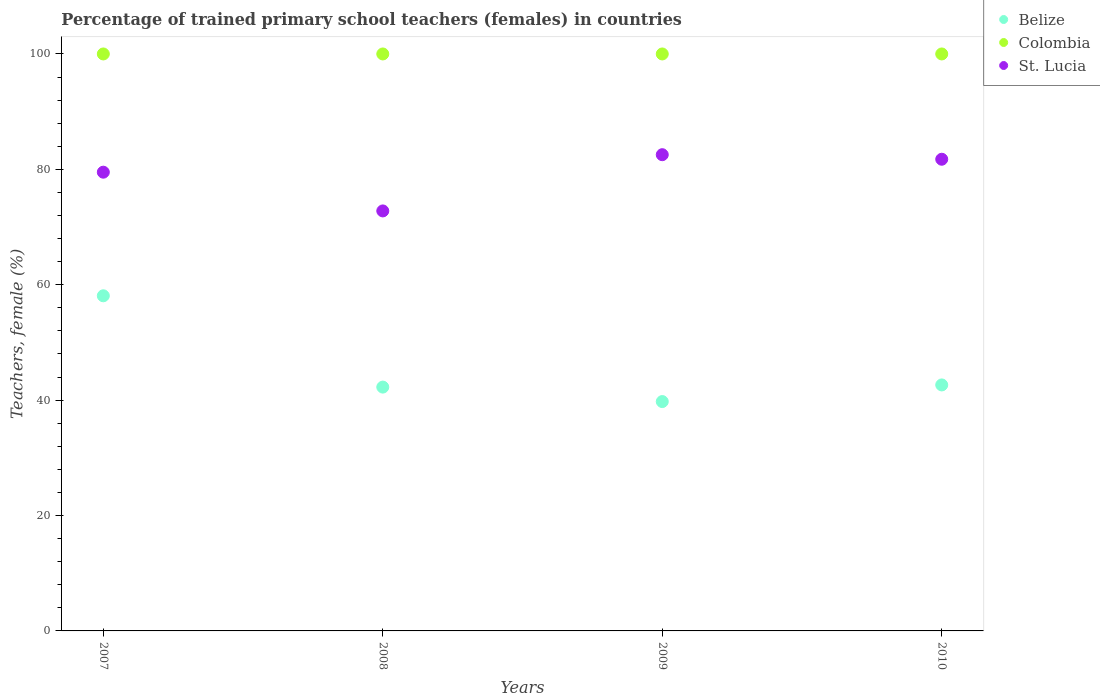Is the number of dotlines equal to the number of legend labels?
Give a very brief answer. Yes. What is the percentage of trained primary school teachers (females) in Belize in 2009?
Your answer should be very brief. 39.75. Across all years, what is the maximum percentage of trained primary school teachers (females) in Belize?
Your response must be concise. 58.08. Across all years, what is the minimum percentage of trained primary school teachers (females) in Belize?
Offer a terse response. 39.75. What is the total percentage of trained primary school teachers (females) in Belize in the graph?
Provide a succinct answer. 182.73. What is the difference between the percentage of trained primary school teachers (females) in Belize in 2008 and that in 2010?
Offer a very short reply. -0.38. What is the difference between the percentage of trained primary school teachers (females) in St. Lucia in 2010 and the percentage of trained primary school teachers (females) in Colombia in 2007?
Provide a succinct answer. -18.25. What is the average percentage of trained primary school teachers (females) in St. Lucia per year?
Make the answer very short. 79.15. In the year 2008, what is the difference between the percentage of trained primary school teachers (females) in Colombia and percentage of trained primary school teachers (females) in Belize?
Keep it short and to the point. 57.74. What is the ratio of the percentage of trained primary school teachers (females) in St. Lucia in 2007 to that in 2010?
Your answer should be compact. 0.97. What is the difference between the highest and the second highest percentage of trained primary school teachers (females) in Belize?
Your response must be concise. 15.45. What is the difference between the highest and the lowest percentage of trained primary school teachers (females) in St. Lucia?
Offer a terse response. 9.75. In how many years, is the percentage of trained primary school teachers (females) in St. Lucia greater than the average percentage of trained primary school teachers (females) in St. Lucia taken over all years?
Keep it short and to the point. 3. Is it the case that in every year, the sum of the percentage of trained primary school teachers (females) in Belize and percentage of trained primary school teachers (females) in St. Lucia  is greater than the percentage of trained primary school teachers (females) in Colombia?
Provide a short and direct response. Yes. Does the percentage of trained primary school teachers (females) in Colombia monotonically increase over the years?
Offer a terse response. No. Is the percentage of trained primary school teachers (females) in St. Lucia strictly less than the percentage of trained primary school teachers (females) in Colombia over the years?
Provide a short and direct response. Yes. Are the values on the major ticks of Y-axis written in scientific E-notation?
Ensure brevity in your answer.  No. How many legend labels are there?
Your response must be concise. 3. What is the title of the graph?
Offer a very short reply. Percentage of trained primary school teachers (females) in countries. What is the label or title of the X-axis?
Your answer should be very brief. Years. What is the label or title of the Y-axis?
Keep it short and to the point. Teachers, female (%). What is the Teachers, female (%) in Belize in 2007?
Provide a succinct answer. 58.08. What is the Teachers, female (%) in Colombia in 2007?
Give a very brief answer. 100. What is the Teachers, female (%) of St. Lucia in 2007?
Ensure brevity in your answer.  79.51. What is the Teachers, female (%) of Belize in 2008?
Keep it short and to the point. 42.26. What is the Teachers, female (%) in Colombia in 2008?
Your answer should be very brief. 100. What is the Teachers, female (%) of St. Lucia in 2008?
Make the answer very short. 72.79. What is the Teachers, female (%) of Belize in 2009?
Make the answer very short. 39.75. What is the Teachers, female (%) of Colombia in 2009?
Your answer should be very brief. 100. What is the Teachers, female (%) of St. Lucia in 2009?
Keep it short and to the point. 82.54. What is the Teachers, female (%) of Belize in 2010?
Ensure brevity in your answer.  42.64. What is the Teachers, female (%) of Colombia in 2010?
Provide a short and direct response. 100. What is the Teachers, female (%) in St. Lucia in 2010?
Give a very brief answer. 81.75. Across all years, what is the maximum Teachers, female (%) of Belize?
Your response must be concise. 58.08. Across all years, what is the maximum Teachers, female (%) in Colombia?
Your response must be concise. 100. Across all years, what is the maximum Teachers, female (%) in St. Lucia?
Ensure brevity in your answer.  82.54. Across all years, what is the minimum Teachers, female (%) of Belize?
Offer a very short reply. 39.75. Across all years, what is the minimum Teachers, female (%) of St. Lucia?
Offer a terse response. 72.79. What is the total Teachers, female (%) in Belize in the graph?
Offer a very short reply. 182.73. What is the total Teachers, female (%) of Colombia in the graph?
Provide a short and direct response. 400. What is the total Teachers, female (%) in St. Lucia in the graph?
Your answer should be very brief. 316.59. What is the difference between the Teachers, female (%) of Belize in 2007 and that in 2008?
Keep it short and to the point. 15.82. What is the difference between the Teachers, female (%) in St. Lucia in 2007 and that in 2008?
Make the answer very short. 6.71. What is the difference between the Teachers, female (%) of Belize in 2007 and that in 2009?
Your response must be concise. 18.33. What is the difference between the Teachers, female (%) of St. Lucia in 2007 and that in 2009?
Ensure brevity in your answer.  -3.03. What is the difference between the Teachers, female (%) of Belize in 2007 and that in 2010?
Offer a very short reply. 15.45. What is the difference between the Teachers, female (%) in St. Lucia in 2007 and that in 2010?
Provide a short and direct response. -2.24. What is the difference between the Teachers, female (%) in Belize in 2008 and that in 2009?
Your answer should be very brief. 2.51. What is the difference between the Teachers, female (%) of St. Lucia in 2008 and that in 2009?
Offer a very short reply. -9.75. What is the difference between the Teachers, female (%) in Belize in 2008 and that in 2010?
Give a very brief answer. -0.38. What is the difference between the Teachers, female (%) in Colombia in 2008 and that in 2010?
Make the answer very short. 0. What is the difference between the Teachers, female (%) of St. Lucia in 2008 and that in 2010?
Provide a succinct answer. -8.96. What is the difference between the Teachers, female (%) in Belize in 2009 and that in 2010?
Provide a succinct answer. -2.88. What is the difference between the Teachers, female (%) in Colombia in 2009 and that in 2010?
Ensure brevity in your answer.  0. What is the difference between the Teachers, female (%) in St. Lucia in 2009 and that in 2010?
Provide a succinct answer. 0.79. What is the difference between the Teachers, female (%) of Belize in 2007 and the Teachers, female (%) of Colombia in 2008?
Make the answer very short. -41.92. What is the difference between the Teachers, female (%) of Belize in 2007 and the Teachers, female (%) of St. Lucia in 2008?
Your answer should be very brief. -14.71. What is the difference between the Teachers, female (%) of Colombia in 2007 and the Teachers, female (%) of St. Lucia in 2008?
Give a very brief answer. 27.21. What is the difference between the Teachers, female (%) of Belize in 2007 and the Teachers, female (%) of Colombia in 2009?
Your response must be concise. -41.92. What is the difference between the Teachers, female (%) of Belize in 2007 and the Teachers, female (%) of St. Lucia in 2009?
Your answer should be compact. -24.45. What is the difference between the Teachers, female (%) in Colombia in 2007 and the Teachers, female (%) in St. Lucia in 2009?
Offer a terse response. 17.46. What is the difference between the Teachers, female (%) in Belize in 2007 and the Teachers, female (%) in Colombia in 2010?
Provide a short and direct response. -41.92. What is the difference between the Teachers, female (%) of Belize in 2007 and the Teachers, female (%) of St. Lucia in 2010?
Make the answer very short. -23.67. What is the difference between the Teachers, female (%) in Colombia in 2007 and the Teachers, female (%) in St. Lucia in 2010?
Provide a short and direct response. 18.25. What is the difference between the Teachers, female (%) of Belize in 2008 and the Teachers, female (%) of Colombia in 2009?
Offer a terse response. -57.74. What is the difference between the Teachers, female (%) of Belize in 2008 and the Teachers, female (%) of St. Lucia in 2009?
Provide a succinct answer. -40.28. What is the difference between the Teachers, female (%) in Colombia in 2008 and the Teachers, female (%) in St. Lucia in 2009?
Your answer should be compact. 17.46. What is the difference between the Teachers, female (%) in Belize in 2008 and the Teachers, female (%) in Colombia in 2010?
Your answer should be very brief. -57.74. What is the difference between the Teachers, female (%) in Belize in 2008 and the Teachers, female (%) in St. Lucia in 2010?
Provide a short and direct response. -39.49. What is the difference between the Teachers, female (%) of Colombia in 2008 and the Teachers, female (%) of St. Lucia in 2010?
Offer a terse response. 18.25. What is the difference between the Teachers, female (%) in Belize in 2009 and the Teachers, female (%) in Colombia in 2010?
Your response must be concise. -60.25. What is the difference between the Teachers, female (%) in Belize in 2009 and the Teachers, female (%) in St. Lucia in 2010?
Your answer should be very brief. -42. What is the difference between the Teachers, female (%) of Colombia in 2009 and the Teachers, female (%) of St. Lucia in 2010?
Your answer should be compact. 18.25. What is the average Teachers, female (%) of Belize per year?
Your response must be concise. 45.68. What is the average Teachers, female (%) in St. Lucia per year?
Provide a succinct answer. 79.15. In the year 2007, what is the difference between the Teachers, female (%) in Belize and Teachers, female (%) in Colombia?
Provide a succinct answer. -41.92. In the year 2007, what is the difference between the Teachers, female (%) of Belize and Teachers, female (%) of St. Lucia?
Provide a succinct answer. -21.42. In the year 2007, what is the difference between the Teachers, female (%) of Colombia and Teachers, female (%) of St. Lucia?
Your response must be concise. 20.49. In the year 2008, what is the difference between the Teachers, female (%) in Belize and Teachers, female (%) in Colombia?
Your answer should be very brief. -57.74. In the year 2008, what is the difference between the Teachers, female (%) in Belize and Teachers, female (%) in St. Lucia?
Provide a succinct answer. -30.53. In the year 2008, what is the difference between the Teachers, female (%) of Colombia and Teachers, female (%) of St. Lucia?
Your response must be concise. 27.21. In the year 2009, what is the difference between the Teachers, female (%) in Belize and Teachers, female (%) in Colombia?
Give a very brief answer. -60.25. In the year 2009, what is the difference between the Teachers, female (%) of Belize and Teachers, female (%) of St. Lucia?
Provide a succinct answer. -42.79. In the year 2009, what is the difference between the Teachers, female (%) of Colombia and Teachers, female (%) of St. Lucia?
Offer a very short reply. 17.46. In the year 2010, what is the difference between the Teachers, female (%) of Belize and Teachers, female (%) of Colombia?
Make the answer very short. -57.36. In the year 2010, what is the difference between the Teachers, female (%) in Belize and Teachers, female (%) in St. Lucia?
Offer a very short reply. -39.12. In the year 2010, what is the difference between the Teachers, female (%) in Colombia and Teachers, female (%) in St. Lucia?
Ensure brevity in your answer.  18.25. What is the ratio of the Teachers, female (%) in Belize in 2007 to that in 2008?
Your answer should be compact. 1.37. What is the ratio of the Teachers, female (%) in St. Lucia in 2007 to that in 2008?
Your answer should be compact. 1.09. What is the ratio of the Teachers, female (%) in Belize in 2007 to that in 2009?
Provide a succinct answer. 1.46. What is the ratio of the Teachers, female (%) of Colombia in 2007 to that in 2009?
Your response must be concise. 1. What is the ratio of the Teachers, female (%) in St. Lucia in 2007 to that in 2009?
Your answer should be very brief. 0.96. What is the ratio of the Teachers, female (%) of Belize in 2007 to that in 2010?
Keep it short and to the point. 1.36. What is the ratio of the Teachers, female (%) of St. Lucia in 2007 to that in 2010?
Offer a very short reply. 0.97. What is the ratio of the Teachers, female (%) in Belize in 2008 to that in 2009?
Ensure brevity in your answer.  1.06. What is the ratio of the Teachers, female (%) in St. Lucia in 2008 to that in 2009?
Your answer should be very brief. 0.88. What is the ratio of the Teachers, female (%) in Colombia in 2008 to that in 2010?
Give a very brief answer. 1. What is the ratio of the Teachers, female (%) in St. Lucia in 2008 to that in 2010?
Provide a succinct answer. 0.89. What is the ratio of the Teachers, female (%) in Belize in 2009 to that in 2010?
Provide a succinct answer. 0.93. What is the ratio of the Teachers, female (%) of Colombia in 2009 to that in 2010?
Provide a short and direct response. 1. What is the ratio of the Teachers, female (%) in St. Lucia in 2009 to that in 2010?
Offer a very short reply. 1.01. What is the difference between the highest and the second highest Teachers, female (%) in Belize?
Provide a succinct answer. 15.45. What is the difference between the highest and the second highest Teachers, female (%) in Colombia?
Your answer should be very brief. 0. What is the difference between the highest and the second highest Teachers, female (%) in St. Lucia?
Offer a terse response. 0.79. What is the difference between the highest and the lowest Teachers, female (%) of Belize?
Keep it short and to the point. 18.33. What is the difference between the highest and the lowest Teachers, female (%) in Colombia?
Your answer should be very brief. 0. What is the difference between the highest and the lowest Teachers, female (%) in St. Lucia?
Keep it short and to the point. 9.75. 